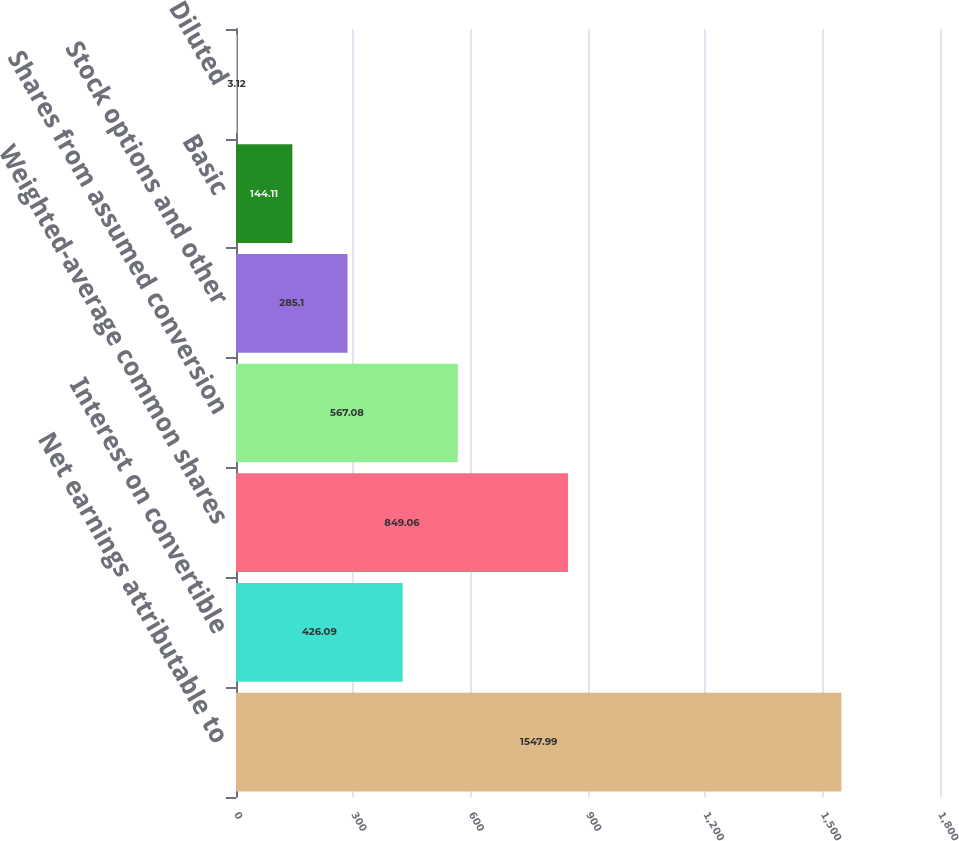<chart> <loc_0><loc_0><loc_500><loc_500><bar_chart><fcel>Net earnings attributable to<fcel>Interest on convertible<fcel>Weighted-average common shares<fcel>Shares from assumed conversion<fcel>Stock options and other<fcel>Basic<fcel>Diluted<nl><fcel>1547.99<fcel>426.09<fcel>849.06<fcel>567.08<fcel>285.1<fcel>144.11<fcel>3.12<nl></chart> 